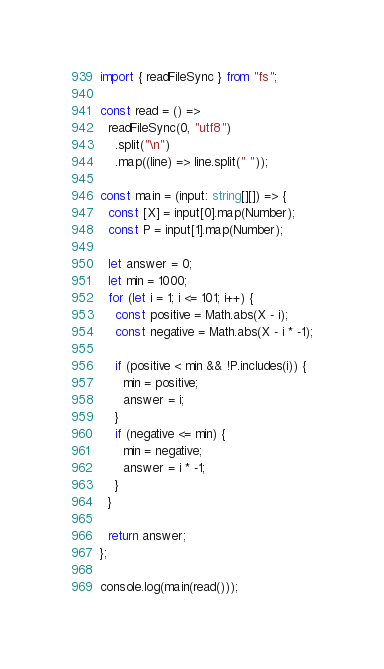<code> <loc_0><loc_0><loc_500><loc_500><_TypeScript_>import { readFileSync } from "fs";

const read = () =>
  readFileSync(0, "utf8")
    .split("\n")
    .map((line) => line.split(" "));

const main = (input: string[][]) => {
  const [X] = input[0].map(Number);
  const P = input[1].map(Number);

  let answer = 0;
  let min = 1000;
  for (let i = 1; i <= 101; i++) {
    const positive = Math.abs(X - i);
    const negative = Math.abs(X - i * -1);

    if (positive < min && !P.includes(i)) {
      min = positive;
      answer = i;
    }
    if (negative <= min) {
      min = negative;
      answer = i * -1;
    }
  }

  return answer;
};

console.log(main(read()));
</code> 